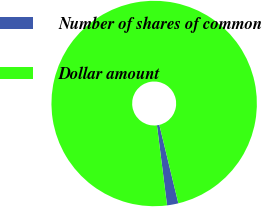Convert chart. <chart><loc_0><loc_0><loc_500><loc_500><pie_chart><fcel>Number of shares of common<fcel>Dollar amount<nl><fcel>1.78%<fcel>98.22%<nl></chart> 